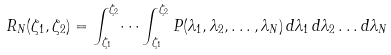Convert formula to latex. <formula><loc_0><loc_0><loc_500><loc_500>R _ { N } ( \zeta _ { 1 } , \zeta _ { 2 } ) = \int _ { \zeta _ { 1 } } ^ { \zeta _ { 2 } } \dots \int _ { \zeta _ { 1 } } ^ { \zeta _ { 2 } } P ( \lambda _ { 1 } , \lambda _ { 2 } , \dots , \lambda _ { N } ) \, d \lambda _ { 1 } \, d \lambda _ { 2 } \dots d \lambda _ { N }</formula> 